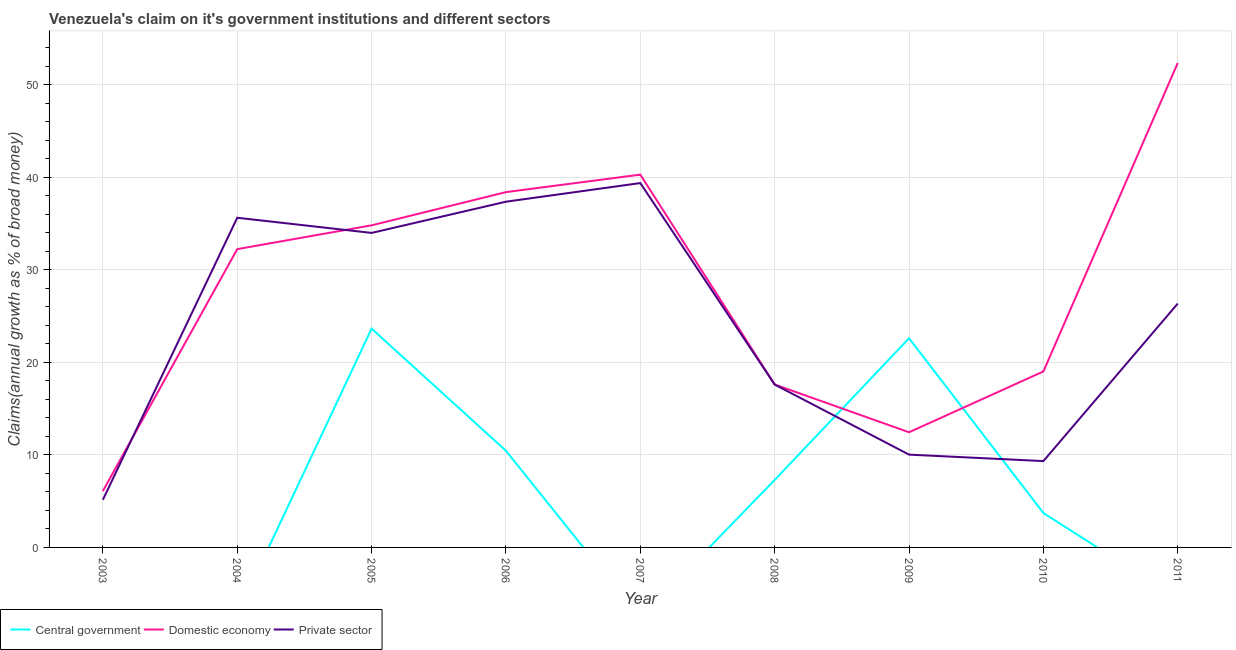What is the percentage of claim on the private sector in 2004?
Your answer should be very brief. 35.64. Across all years, what is the maximum percentage of claim on the central government?
Your answer should be very brief. 23.66. What is the total percentage of claim on the domestic economy in the graph?
Your answer should be compact. 253.36. What is the difference between the percentage of claim on the private sector in 2005 and that in 2008?
Give a very brief answer. 16.4. What is the difference between the percentage of claim on the central government in 2006 and the percentage of claim on the private sector in 2004?
Keep it short and to the point. -25.19. What is the average percentage of claim on the central government per year?
Ensure brevity in your answer.  7.53. In the year 2008, what is the difference between the percentage of claim on the domestic economy and percentage of claim on the central government?
Your answer should be very brief. 10.32. What is the ratio of the percentage of claim on the central government in 2006 to that in 2010?
Provide a succinct answer. 2.81. What is the difference between the highest and the second highest percentage of claim on the central government?
Your response must be concise. 1.04. What is the difference between the highest and the lowest percentage of claim on the central government?
Provide a short and direct response. 23.66. Does the percentage of claim on the private sector monotonically increase over the years?
Your response must be concise. No. Is the percentage of claim on the domestic economy strictly greater than the percentage of claim on the central government over the years?
Provide a short and direct response. No. Is the percentage of claim on the domestic economy strictly less than the percentage of claim on the private sector over the years?
Provide a short and direct response. No. What is the difference between two consecutive major ticks on the Y-axis?
Your answer should be very brief. 10. Does the graph contain grids?
Make the answer very short. Yes. How many legend labels are there?
Your answer should be very brief. 3. What is the title of the graph?
Make the answer very short. Venezuela's claim on it's government institutions and different sectors. What is the label or title of the Y-axis?
Make the answer very short. Claims(annual growth as % of broad money). What is the Claims(annual growth as % of broad money) of Domestic economy in 2003?
Ensure brevity in your answer.  6.09. What is the Claims(annual growth as % of broad money) in Private sector in 2003?
Your answer should be very brief. 5.15. What is the Claims(annual growth as % of broad money) of Central government in 2004?
Provide a short and direct response. 0. What is the Claims(annual growth as % of broad money) in Domestic economy in 2004?
Your response must be concise. 32.25. What is the Claims(annual growth as % of broad money) in Private sector in 2004?
Make the answer very short. 35.64. What is the Claims(annual growth as % of broad money) in Central government in 2005?
Make the answer very short. 23.66. What is the Claims(annual growth as % of broad money) in Domestic economy in 2005?
Your answer should be very brief. 34.83. What is the Claims(annual growth as % of broad money) of Private sector in 2005?
Keep it short and to the point. 34.01. What is the Claims(annual growth as % of broad money) of Central government in 2006?
Offer a very short reply. 10.45. What is the Claims(annual growth as % of broad money) of Domestic economy in 2006?
Offer a terse response. 38.42. What is the Claims(annual growth as % of broad money) in Private sector in 2006?
Your answer should be very brief. 37.38. What is the Claims(annual growth as % of broad money) in Domestic economy in 2007?
Provide a succinct answer. 40.31. What is the Claims(annual growth as % of broad money) in Private sector in 2007?
Provide a short and direct response. 39.39. What is the Claims(annual growth as % of broad money) in Central government in 2008?
Make the answer very short. 7.29. What is the Claims(annual growth as % of broad money) of Domestic economy in 2008?
Offer a very short reply. 17.61. What is the Claims(annual growth as % of broad money) of Private sector in 2008?
Your response must be concise. 17.61. What is the Claims(annual growth as % of broad money) of Central government in 2009?
Your response must be concise. 22.61. What is the Claims(annual growth as % of broad money) of Domestic economy in 2009?
Your response must be concise. 12.45. What is the Claims(annual growth as % of broad money) of Private sector in 2009?
Give a very brief answer. 10.03. What is the Claims(annual growth as % of broad money) of Central government in 2010?
Ensure brevity in your answer.  3.72. What is the Claims(annual growth as % of broad money) of Domestic economy in 2010?
Your answer should be very brief. 19.03. What is the Claims(annual growth as % of broad money) of Private sector in 2010?
Ensure brevity in your answer.  9.33. What is the Claims(annual growth as % of broad money) in Central government in 2011?
Make the answer very short. 0. What is the Claims(annual growth as % of broad money) in Domestic economy in 2011?
Make the answer very short. 52.38. What is the Claims(annual growth as % of broad money) in Private sector in 2011?
Your answer should be very brief. 26.37. Across all years, what is the maximum Claims(annual growth as % of broad money) in Central government?
Provide a succinct answer. 23.66. Across all years, what is the maximum Claims(annual growth as % of broad money) in Domestic economy?
Offer a terse response. 52.38. Across all years, what is the maximum Claims(annual growth as % of broad money) in Private sector?
Offer a very short reply. 39.39. Across all years, what is the minimum Claims(annual growth as % of broad money) of Domestic economy?
Make the answer very short. 6.09. Across all years, what is the minimum Claims(annual growth as % of broad money) in Private sector?
Your answer should be very brief. 5.15. What is the total Claims(annual growth as % of broad money) in Central government in the graph?
Your response must be concise. 67.74. What is the total Claims(annual growth as % of broad money) of Domestic economy in the graph?
Provide a short and direct response. 253.36. What is the total Claims(annual growth as % of broad money) of Private sector in the graph?
Provide a short and direct response. 214.92. What is the difference between the Claims(annual growth as % of broad money) of Domestic economy in 2003 and that in 2004?
Your response must be concise. -26.16. What is the difference between the Claims(annual growth as % of broad money) of Private sector in 2003 and that in 2004?
Your answer should be very brief. -30.49. What is the difference between the Claims(annual growth as % of broad money) of Domestic economy in 2003 and that in 2005?
Provide a short and direct response. -28.73. What is the difference between the Claims(annual growth as % of broad money) in Private sector in 2003 and that in 2005?
Provide a succinct answer. -28.86. What is the difference between the Claims(annual growth as % of broad money) of Domestic economy in 2003 and that in 2006?
Provide a short and direct response. -32.32. What is the difference between the Claims(annual growth as % of broad money) in Private sector in 2003 and that in 2006?
Your response must be concise. -32.23. What is the difference between the Claims(annual growth as % of broad money) of Domestic economy in 2003 and that in 2007?
Your answer should be compact. -34.21. What is the difference between the Claims(annual growth as % of broad money) in Private sector in 2003 and that in 2007?
Your response must be concise. -34.24. What is the difference between the Claims(annual growth as % of broad money) in Domestic economy in 2003 and that in 2008?
Your answer should be very brief. -11.52. What is the difference between the Claims(annual growth as % of broad money) of Private sector in 2003 and that in 2008?
Offer a very short reply. -12.46. What is the difference between the Claims(annual growth as % of broad money) in Domestic economy in 2003 and that in 2009?
Make the answer very short. -6.36. What is the difference between the Claims(annual growth as % of broad money) in Private sector in 2003 and that in 2009?
Provide a succinct answer. -4.88. What is the difference between the Claims(annual growth as % of broad money) in Domestic economy in 2003 and that in 2010?
Make the answer very short. -12.93. What is the difference between the Claims(annual growth as % of broad money) in Private sector in 2003 and that in 2010?
Offer a very short reply. -4.18. What is the difference between the Claims(annual growth as % of broad money) in Domestic economy in 2003 and that in 2011?
Offer a very short reply. -46.28. What is the difference between the Claims(annual growth as % of broad money) of Private sector in 2003 and that in 2011?
Provide a short and direct response. -21.22. What is the difference between the Claims(annual growth as % of broad money) of Domestic economy in 2004 and that in 2005?
Provide a succinct answer. -2.58. What is the difference between the Claims(annual growth as % of broad money) in Private sector in 2004 and that in 2005?
Your answer should be compact. 1.64. What is the difference between the Claims(annual growth as % of broad money) in Domestic economy in 2004 and that in 2006?
Provide a succinct answer. -6.17. What is the difference between the Claims(annual growth as % of broad money) of Private sector in 2004 and that in 2006?
Offer a terse response. -1.74. What is the difference between the Claims(annual growth as % of broad money) in Domestic economy in 2004 and that in 2007?
Ensure brevity in your answer.  -8.06. What is the difference between the Claims(annual growth as % of broad money) of Private sector in 2004 and that in 2007?
Ensure brevity in your answer.  -3.75. What is the difference between the Claims(annual growth as % of broad money) of Domestic economy in 2004 and that in 2008?
Offer a terse response. 14.64. What is the difference between the Claims(annual growth as % of broad money) of Private sector in 2004 and that in 2008?
Give a very brief answer. 18.03. What is the difference between the Claims(annual growth as % of broad money) of Domestic economy in 2004 and that in 2009?
Provide a short and direct response. 19.8. What is the difference between the Claims(annual growth as % of broad money) in Private sector in 2004 and that in 2009?
Ensure brevity in your answer.  25.61. What is the difference between the Claims(annual growth as % of broad money) of Domestic economy in 2004 and that in 2010?
Offer a terse response. 13.22. What is the difference between the Claims(annual growth as % of broad money) of Private sector in 2004 and that in 2010?
Your answer should be compact. 26.31. What is the difference between the Claims(annual growth as % of broad money) of Domestic economy in 2004 and that in 2011?
Provide a succinct answer. -20.13. What is the difference between the Claims(annual growth as % of broad money) in Private sector in 2004 and that in 2011?
Offer a very short reply. 9.28. What is the difference between the Claims(annual growth as % of broad money) in Central government in 2005 and that in 2006?
Provide a succinct answer. 13.21. What is the difference between the Claims(annual growth as % of broad money) in Domestic economy in 2005 and that in 2006?
Give a very brief answer. -3.59. What is the difference between the Claims(annual growth as % of broad money) of Private sector in 2005 and that in 2006?
Provide a succinct answer. -3.37. What is the difference between the Claims(annual growth as % of broad money) in Domestic economy in 2005 and that in 2007?
Ensure brevity in your answer.  -5.48. What is the difference between the Claims(annual growth as % of broad money) of Private sector in 2005 and that in 2007?
Give a very brief answer. -5.39. What is the difference between the Claims(annual growth as % of broad money) in Central government in 2005 and that in 2008?
Make the answer very short. 16.36. What is the difference between the Claims(annual growth as % of broad money) in Domestic economy in 2005 and that in 2008?
Make the answer very short. 17.21. What is the difference between the Claims(annual growth as % of broad money) in Private sector in 2005 and that in 2008?
Your answer should be very brief. 16.4. What is the difference between the Claims(annual growth as % of broad money) in Central government in 2005 and that in 2009?
Offer a very short reply. 1.04. What is the difference between the Claims(annual growth as % of broad money) of Domestic economy in 2005 and that in 2009?
Offer a very short reply. 22.37. What is the difference between the Claims(annual growth as % of broad money) of Private sector in 2005 and that in 2009?
Provide a succinct answer. 23.97. What is the difference between the Claims(annual growth as % of broad money) of Central government in 2005 and that in 2010?
Your answer should be very brief. 19.94. What is the difference between the Claims(annual growth as % of broad money) in Domestic economy in 2005 and that in 2010?
Offer a terse response. 15.8. What is the difference between the Claims(annual growth as % of broad money) of Private sector in 2005 and that in 2010?
Your answer should be very brief. 24.67. What is the difference between the Claims(annual growth as % of broad money) of Domestic economy in 2005 and that in 2011?
Offer a very short reply. -17.55. What is the difference between the Claims(annual growth as % of broad money) of Private sector in 2005 and that in 2011?
Ensure brevity in your answer.  7.64. What is the difference between the Claims(annual growth as % of broad money) in Domestic economy in 2006 and that in 2007?
Offer a very short reply. -1.89. What is the difference between the Claims(annual growth as % of broad money) of Private sector in 2006 and that in 2007?
Give a very brief answer. -2.01. What is the difference between the Claims(annual growth as % of broad money) in Central government in 2006 and that in 2008?
Offer a terse response. 3.16. What is the difference between the Claims(annual growth as % of broad money) in Domestic economy in 2006 and that in 2008?
Offer a terse response. 20.8. What is the difference between the Claims(annual growth as % of broad money) in Private sector in 2006 and that in 2008?
Ensure brevity in your answer.  19.77. What is the difference between the Claims(annual growth as % of broad money) of Central government in 2006 and that in 2009?
Make the answer very short. -12.16. What is the difference between the Claims(annual growth as % of broad money) of Domestic economy in 2006 and that in 2009?
Keep it short and to the point. 25.96. What is the difference between the Claims(annual growth as % of broad money) in Private sector in 2006 and that in 2009?
Provide a succinct answer. 27.35. What is the difference between the Claims(annual growth as % of broad money) of Central government in 2006 and that in 2010?
Give a very brief answer. 6.73. What is the difference between the Claims(annual growth as % of broad money) of Domestic economy in 2006 and that in 2010?
Your answer should be compact. 19.39. What is the difference between the Claims(annual growth as % of broad money) of Private sector in 2006 and that in 2010?
Offer a terse response. 28.05. What is the difference between the Claims(annual growth as % of broad money) in Domestic economy in 2006 and that in 2011?
Offer a terse response. -13.96. What is the difference between the Claims(annual growth as % of broad money) in Private sector in 2006 and that in 2011?
Offer a terse response. 11.01. What is the difference between the Claims(annual growth as % of broad money) of Domestic economy in 2007 and that in 2008?
Keep it short and to the point. 22.69. What is the difference between the Claims(annual growth as % of broad money) in Private sector in 2007 and that in 2008?
Your answer should be compact. 21.78. What is the difference between the Claims(annual growth as % of broad money) in Domestic economy in 2007 and that in 2009?
Offer a terse response. 27.86. What is the difference between the Claims(annual growth as % of broad money) of Private sector in 2007 and that in 2009?
Provide a short and direct response. 29.36. What is the difference between the Claims(annual growth as % of broad money) of Domestic economy in 2007 and that in 2010?
Your answer should be very brief. 21.28. What is the difference between the Claims(annual growth as % of broad money) of Private sector in 2007 and that in 2010?
Provide a short and direct response. 30.06. What is the difference between the Claims(annual growth as % of broad money) in Domestic economy in 2007 and that in 2011?
Offer a very short reply. -12.07. What is the difference between the Claims(annual growth as % of broad money) of Private sector in 2007 and that in 2011?
Your answer should be compact. 13.03. What is the difference between the Claims(annual growth as % of broad money) of Central government in 2008 and that in 2009?
Your answer should be very brief. -15.32. What is the difference between the Claims(annual growth as % of broad money) in Domestic economy in 2008 and that in 2009?
Your answer should be compact. 5.16. What is the difference between the Claims(annual growth as % of broad money) in Private sector in 2008 and that in 2009?
Give a very brief answer. 7.58. What is the difference between the Claims(annual growth as % of broad money) of Central government in 2008 and that in 2010?
Your answer should be very brief. 3.57. What is the difference between the Claims(annual growth as % of broad money) of Domestic economy in 2008 and that in 2010?
Your response must be concise. -1.41. What is the difference between the Claims(annual growth as % of broad money) of Private sector in 2008 and that in 2010?
Ensure brevity in your answer.  8.27. What is the difference between the Claims(annual growth as % of broad money) in Domestic economy in 2008 and that in 2011?
Offer a very short reply. -34.77. What is the difference between the Claims(annual growth as % of broad money) of Private sector in 2008 and that in 2011?
Your answer should be very brief. -8.76. What is the difference between the Claims(annual growth as % of broad money) of Central government in 2009 and that in 2010?
Keep it short and to the point. 18.89. What is the difference between the Claims(annual growth as % of broad money) in Domestic economy in 2009 and that in 2010?
Offer a terse response. -6.57. What is the difference between the Claims(annual growth as % of broad money) in Private sector in 2009 and that in 2010?
Provide a succinct answer. 0.7. What is the difference between the Claims(annual growth as % of broad money) in Domestic economy in 2009 and that in 2011?
Your response must be concise. -39.93. What is the difference between the Claims(annual growth as % of broad money) of Private sector in 2009 and that in 2011?
Ensure brevity in your answer.  -16.33. What is the difference between the Claims(annual growth as % of broad money) of Domestic economy in 2010 and that in 2011?
Make the answer very short. -33.35. What is the difference between the Claims(annual growth as % of broad money) of Private sector in 2010 and that in 2011?
Your answer should be very brief. -17.03. What is the difference between the Claims(annual growth as % of broad money) of Domestic economy in 2003 and the Claims(annual growth as % of broad money) of Private sector in 2004?
Ensure brevity in your answer.  -29.55. What is the difference between the Claims(annual growth as % of broad money) of Domestic economy in 2003 and the Claims(annual growth as % of broad money) of Private sector in 2005?
Make the answer very short. -27.91. What is the difference between the Claims(annual growth as % of broad money) of Domestic economy in 2003 and the Claims(annual growth as % of broad money) of Private sector in 2006?
Your response must be concise. -31.29. What is the difference between the Claims(annual growth as % of broad money) of Domestic economy in 2003 and the Claims(annual growth as % of broad money) of Private sector in 2007?
Give a very brief answer. -33.3. What is the difference between the Claims(annual growth as % of broad money) in Domestic economy in 2003 and the Claims(annual growth as % of broad money) in Private sector in 2008?
Your response must be concise. -11.52. What is the difference between the Claims(annual growth as % of broad money) of Domestic economy in 2003 and the Claims(annual growth as % of broad money) of Private sector in 2009?
Give a very brief answer. -3.94. What is the difference between the Claims(annual growth as % of broad money) in Domestic economy in 2003 and the Claims(annual growth as % of broad money) in Private sector in 2010?
Give a very brief answer. -3.24. What is the difference between the Claims(annual growth as % of broad money) in Domestic economy in 2003 and the Claims(annual growth as % of broad money) in Private sector in 2011?
Provide a short and direct response. -20.27. What is the difference between the Claims(annual growth as % of broad money) of Domestic economy in 2004 and the Claims(annual growth as % of broad money) of Private sector in 2005?
Your answer should be very brief. -1.76. What is the difference between the Claims(annual growth as % of broad money) of Domestic economy in 2004 and the Claims(annual growth as % of broad money) of Private sector in 2006?
Ensure brevity in your answer.  -5.13. What is the difference between the Claims(annual growth as % of broad money) of Domestic economy in 2004 and the Claims(annual growth as % of broad money) of Private sector in 2007?
Provide a succinct answer. -7.14. What is the difference between the Claims(annual growth as % of broad money) in Domestic economy in 2004 and the Claims(annual growth as % of broad money) in Private sector in 2008?
Your answer should be very brief. 14.64. What is the difference between the Claims(annual growth as % of broad money) of Domestic economy in 2004 and the Claims(annual growth as % of broad money) of Private sector in 2009?
Your answer should be very brief. 22.22. What is the difference between the Claims(annual growth as % of broad money) of Domestic economy in 2004 and the Claims(annual growth as % of broad money) of Private sector in 2010?
Offer a terse response. 22.91. What is the difference between the Claims(annual growth as % of broad money) in Domestic economy in 2004 and the Claims(annual growth as % of broad money) in Private sector in 2011?
Your answer should be compact. 5.88. What is the difference between the Claims(annual growth as % of broad money) of Central government in 2005 and the Claims(annual growth as % of broad money) of Domestic economy in 2006?
Your response must be concise. -14.76. What is the difference between the Claims(annual growth as % of broad money) of Central government in 2005 and the Claims(annual growth as % of broad money) of Private sector in 2006?
Your answer should be compact. -13.72. What is the difference between the Claims(annual growth as % of broad money) in Domestic economy in 2005 and the Claims(annual growth as % of broad money) in Private sector in 2006?
Keep it short and to the point. -2.55. What is the difference between the Claims(annual growth as % of broad money) in Central government in 2005 and the Claims(annual growth as % of broad money) in Domestic economy in 2007?
Your answer should be very brief. -16.65. What is the difference between the Claims(annual growth as % of broad money) in Central government in 2005 and the Claims(annual growth as % of broad money) in Private sector in 2007?
Provide a short and direct response. -15.74. What is the difference between the Claims(annual growth as % of broad money) in Domestic economy in 2005 and the Claims(annual growth as % of broad money) in Private sector in 2007?
Offer a terse response. -4.57. What is the difference between the Claims(annual growth as % of broad money) of Central government in 2005 and the Claims(annual growth as % of broad money) of Domestic economy in 2008?
Provide a succinct answer. 6.04. What is the difference between the Claims(annual growth as % of broad money) of Central government in 2005 and the Claims(annual growth as % of broad money) of Private sector in 2008?
Your response must be concise. 6.05. What is the difference between the Claims(annual growth as % of broad money) of Domestic economy in 2005 and the Claims(annual growth as % of broad money) of Private sector in 2008?
Ensure brevity in your answer.  17.22. What is the difference between the Claims(annual growth as % of broad money) of Central government in 2005 and the Claims(annual growth as % of broad money) of Domestic economy in 2009?
Ensure brevity in your answer.  11.21. What is the difference between the Claims(annual growth as % of broad money) of Central government in 2005 and the Claims(annual growth as % of broad money) of Private sector in 2009?
Ensure brevity in your answer.  13.62. What is the difference between the Claims(annual growth as % of broad money) in Domestic economy in 2005 and the Claims(annual growth as % of broad money) in Private sector in 2009?
Offer a very short reply. 24.79. What is the difference between the Claims(annual growth as % of broad money) of Central government in 2005 and the Claims(annual growth as % of broad money) of Domestic economy in 2010?
Give a very brief answer. 4.63. What is the difference between the Claims(annual growth as % of broad money) in Central government in 2005 and the Claims(annual growth as % of broad money) in Private sector in 2010?
Keep it short and to the point. 14.32. What is the difference between the Claims(annual growth as % of broad money) in Domestic economy in 2005 and the Claims(annual growth as % of broad money) in Private sector in 2010?
Ensure brevity in your answer.  25.49. What is the difference between the Claims(annual growth as % of broad money) of Central government in 2005 and the Claims(annual growth as % of broad money) of Domestic economy in 2011?
Your response must be concise. -28.72. What is the difference between the Claims(annual growth as % of broad money) in Central government in 2005 and the Claims(annual growth as % of broad money) in Private sector in 2011?
Make the answer very short. -2.71. What is the difference between the Claims(annual growth as % of broad money) of Domestic economy in 2005 and the Claims(annual growth as % of broad money) of Private sector in 2011?
Offer a very short reply. 8.46. What is the difference between the Claims(annual growth as % of broad money) in Central government in 2006 and the Claims(annual growth as % of broad money) in Domestic economy in 2007?
Offer a very short reply. -29.86. What is the difference between the Claims(annual growth as % of broad money) of Central government in 2006 and the Claims(annual growth as % of broad money) of Private sector in 2007?
Offer a very short reply. -28.94. What is the difference between the Claims(annual growth as % of broad money) in Domestic economy in 2006 and the Claims(annual growth as % of broad money) in Private sector in 2007?
Ensure brevity in your answer.  -0.98. What is the difference between the Claims(annual growth as % of broad money) in Central government in 2006 and the Claims(annual growth as % of broad money) in Domestic economy in 2008?
Provide a succinct answer. -7.16. What is the difference between the Claims(annual growth as % of broad money) of Central government in 2006 and the Claims(annual growth as % of broad money) of Private sector in 2008?
Provide a succinct answer. -7.16. What is the difference between the Claims(annual growth as % of broad money) in Domestic economy in 2006 and the Claims(annual growth as % of broad money) in Private sector in 2008?
Offer a very short reply. 20.81. What is the difference between the Claims(annual growth as % of broad money) in Central government in 2006 and the Claims(annual growth as % of broad money) in Domestic economy in 2009?
Your response must be concise. -2. What is the difference between the Claims(annual growth as % of broad money) of Central government in 2006 and the Claims(annual growth as % of broad money) of Private sector in 2009?
Provide a succinct answer. 0.42. What is the difference between the Claims(annual growth as % of broad money) in Domestic economy in 2006 and the Claims(annual growth as % of broad money) in Private sector in 2009?
Make the answer very short. 28.38. What is the difference between the Claims(annual growth as % of broad money) in Central government in 2006 and the Claims(annual growth as % of broad money) in Domestic economy in 2010?
Provide a succinct answer. -8.57. What is the difference between the Claims(annual growth as % of broad money) in Central government in 2006 and the Claims(annual growth as % of broad money) in Private sector in 2010?
Give a very brief answer. 1.12. What is the difference between the Claims(annual growth as % of broad money) in Domestic economy in 2006 and the Claims(annual growth as % of broad money) in Private sector in 2010?
Keep it short and to the point. 29.08. What is the difference between the Claims(annual growth as % of broad money) of Central government in 2006 and the Claims(annual growth as % of broad money) of Domestic economy in 2011?
Keep it short and to the point. -41.93. What is the difference between the Claims(annual growth as % of broad money) of Central government in 2006 and the Claims(annual growth as % of broad money) of Private sector in 2011?
Provide a succinct answer. -15.91. What is the difference between the Claims(annual growth as % of broad money) in Domestic economy in 2006 and the Claims(annual growth as % of broad money) in Private sector in 2011?
Provide a short and direct response. 12.05. What is the difference between the Claims(annual growth as % of broad money) in Domestic economy in 2007 and the Claims(annual growth as % of broad money) in Private sector in 2008?
Offer a terse response. 22.7. What is the difference between the Claims(annual growth as % of broad money) of Domestic economy in 2007 and the Claims(annual growth as % of broad money) of Private sector in 2009?
Your answer should be compact. 30.27. What is the difference between the Claims(annual growth as % of broad money) of Domestic economy in 2007 and the Claims(annual growth as % of broad money) of Private sector in 2010?
Make the answer very short. 30.97. What is the difference between the Claims(annual growth as % of broad money) of Domestic economy in 2007 and the Claims(annual growth as % of broad money) of Private sector in 2011?
Your response must be concise. 13.94. What is the difference between the Claims(annual growth as % of broad money) in Central government in 2008 and the Claims(annual growth as % of broad money) in Domestic economy in 2009?
Offer a terse response. -5.16. What is the difference between the Claims(annual growth as % of broad money) in Central government in 2008 and the Claims(annual growth as % of broad money) in Private sector in 2009?
Keep it short and to the point. -2.74. What is the difference between the Claims(annual growth as % of broad money) in Domestic economy in 2008 and the Claims(annual growth as % of broad money) in Private sector in 2009?
Offer a very short reply. 7.58. What is the difference between the Claims(annual growth as % of broad money) of Central government in 2008 and the Claims(annual growth as % of broad money) of Domestic economy in 2010?
Offer a terse response. -11.73. What is the difference between the Claims(annual growth as % of broad money) of Central government in 2008 and the Claims(annual growth as % of broad money) of Private sector in 2010?
Offer a terse response. -2.04. What is the difference between the Claims(annual growth as % of broad money) of Domestic economy in 2008 and the Claims(annual growth as % of broad money) of Private sector in 2010?
Your response must be concise. 8.28. What is the difference between the Claims(annual growth as % of broad money) in Central government in 2008 and the Claims(annual growth as % of broad money) in Domestic economy in 2011?
Make the answer very short. -45.09. What is the difference between the Claims(annual growth as % of broad money) of Central government in 2008 and the Claims(annual growth as % of broad money) of Private sector in 2011?
Provide a succinct answer. -19.07. What is the difference between the Claims(annual growth as % of broad money) of Domestic economy in 2008 and the Claims(annual growth as % of broad money) of Private sector in 2011?
Provide a short and direct response. -8.75. What is the difference between the Claims(annual growth as % of broad money) of Central government in 2009 and the Claims(annual growth as % of broad money) of Domestic economy in 2010?
Your answer should be compact. 3.59. What is the difference between the Claims(annual growth as % of broad money) of Central government in 2009 and the Claims(annual growth as % of broad money) of Private sector in 2010?
Your answer should be compact. 13.28. What is the difference between the Claims(annual growth as % of broad money) in Domestic economy in 2009 and the Claims(annual growth as % of broad money) in Private sector in 2010?
Give a very brief answer. 3.12. What is the difference between the Claims(annual growth as % of broad money) of Central government in 2009 and the Claims(annual growth as % of broad money) of Domestic economy in 2011?
Your answer should be compact. -29.77. What is the difference between the Claims(annual growth as % of broad money) of Central government in 2009 and the Claims(annual growth as % of broad money) of Private sector in 2011?
Keep it short and to the point. -3.75. What is the difference between the Claims(annual growth as % of broad money) of Domestic economy in 2009 and the Claims(annual growth as % of broad money) of Private sector in 2011?
Keep it short and to the point. -13.91. What is the difference between the Claims(annual growth as % of broad money) in Central government in 2010 and the Claims(annual growth as % of broad money) in Domestic economy in 2011?
Ensure brevity in your answer.  -48.66. What is the difference between the Claims(annual growth as % of broad money) of Central government in 2010 and the Claims(annual growth as % of broad money) of Private sector in 2011?
Keep it short and to the point. -22.64. What is the difference between the Claims(annual growth as % of broad money) of Domestic economy in 2010 and the Claims(annual growth as % of broad money) of Private sector in 2011?
Make the answer very short. -7.34. What is the average Claims(annual growth as % of broad money) of Central government per year?
Keep it short and to the point. 7.53. What is the average Claims(annual growth as % of broad money) in Domestic economy per year?
Provide a succinct answer. 28.15. What is the average Claims(annual growth as % of broad money) of Private sector per year?
Provide a succinct answer. 23.88. In the year 2003, what is the difference between the Claims(annual growth as % of broad money) of Domestic economy and Claims(annual growth as % of broad money) of Private sector?
Provide a succinct answer. 0.94. In the year 2004, what is the difference between the Claims(annual growth as % of broad money) in Domestic economy and Claims(annual growth as % of broad money) in Private sector?
Your answer should be compact. -3.39. In the year 2005, what is the difference between the Claims(annual growth as % of broad money) in Central government and Claims(annual growth as % of broad money) in Domestic economy?
Offer a terse response. -11.17. In the year 2005, what is the difference between the Claims(annual growth as % of broad money) in Central government and Claims(annual growth as % of broad money) in Private sector?
Offer a terse response. -10.35. In the year 2005, what is the difference between the Claims(annual growth as % of broad money) of Domestic economy and Claims(annual growth as % of broad money) of Private sector?
Offer a very short reply. 0.82. In the year 2006, what is the difference between the Claims(annual growth as % of broad money) in Central government and Claims(annual growth as % of broad money) in Domestic economy?
Provide a short and direct response. -27.96. In the year 2006, what is the difference between the Claims(annual growth as % of broad money) in Central government and Claims(annual growth as % of broad money) in Private sector?
Offer a very short reply. -26.93. In the year 2006, what is the difference between the Claims(annual growth as % of broad money) of Domestic economy and Claims(annual growth as % of broad money) of Private sector?
Provide a succinct answer. 1.04. In the year 2007, what is the difference between the Claims(annual growth as % of broad money) in Domestic economy and Claims(annual growth as % of broad money) in Private sector?
Make the answer very short. 0.91. In the year 2008, what is the difference between the Claims(annual growth as % of broad money) of Central government and Claims(annual growth as % of broad money) of Domestic economy?
Provide a succinct answer. -10.32. In the year 2008, what is the difference between the Claims(annual growth as % of broad money) in Central government and Claims(annual growth as % of broad money) in Private sector?
Ensure brevity in your answer.  -10.32. In the year 2008, what is the difference between the Claims(annual growth as % of broad money) of Domestic economy and Claims(annual growth as % of broad money) of Private sector?
Keep it short and to the point. 0. In the year 2009, what is the difference between the Claims(annual growth as % of broad money) in Central government and Claims(annual growth as % of broad money) in Domestic economy?
Offer a terse response. 10.16. In the year 2009, what is the difference between the Claims(annual growth as % of broad money) in Central government and Claims(annual growth as % of broad money) in Private sector?
Offer a very short reply. 12.58. In the year 2009, what is the difference between the Claims(annual growth as % of broad money) in Domestic economy and Claims(annual growth as % of broad money) in Private sector?
Give a very brief answer. 2.42. In the year 2010, what is the difference between the Claims(annual growth as % of broad money) in Central government and Claims(annual growth as % of broad money) in Domestic economy?
Your answer should be very brief. -15.3. In the year 2010, what is the difference between the Claims(annual growth as % of broad money) of Central government and Claims(annual growth as % of broad money) of Private sector?
Provide a succinct answer. -5.61. In the year 2010, what is the difference between the Claims(annual growth as % of broad money) of Domestic economy and Claims(annual growth as % of broad money) of Private sector?
Offer a terse response. 9.69. In the year 2011, what is the difference between the Claims(annual growth as % of broad money) in Domestic economy and Claims(annual growth as % of broad money) in Private sector?
Give a very brief answer. 26.01. What is the ratio of the Claims(annual growth as % of broad money) of Domestic economy in 2003 to that in 2004?
Provide a short and direct response. 0.19. What is the ratio of the Claims(annual growth as % of broad money) of Private sector in 2003 to that in 2004?
Your answer should be very brief. 0.14. What is the ratio of the Claims(annual growth as % of broad money) of Domestic economy in 2003 to that in 2005?
Provide a succinct answer. 0.17. What is the ratio of the Claims(annual growth as % of broad money) in Private sector in 2003 to that in 2005?
Offer a terse response. 0.15. What is the ratio of the Claims(annual growth as % of broad money) in Domestic economy in 2003 to that in 2006?
Provide a short and direct response. 0.16. What is the ratio of the Claims(annual growth as % of broad money) in Private sector in 2003 to that in 2006?
Provide a short and direct response. 0.14. What is the ratio of the Claims(annual growth as % of broad money) of Domestic economy in 2003 to that in 2007?
Provide a short and direct response. 0.15. What is the ratio of the Claims(annual growth as % of broad money) of Private sector in 2003 to that in 2007?
Offer a terse response. 0.13. What is the ratio of the Claims(annual growth as % of broad money) of Domestic economy in 2003 to that in 2008?
Give a very brief answer. 0.35. What is the ratio of the Claims(annual growth as % of broad money) of Private sector in 2003 to that in 2008?
Offer a very short reply. 0.29. What is the ratio of the Claims(annual growth as % of broad money) in Domestic economy in 2003 to that in 2009?
Give a very brief answer. 0.49. What is the ratio of the Claims(annual growth as % of broad money) in Private sector in 2003 to that in 2009?
Ensure brevity in your answer.  0.51. What is the ratio of the Claims(annual growth as % of broad money) of Domestic economy in 2003 to that in 2010?
Keep it short and to the point. 0.32. What is the ratio of the Claims(annual growth as % of broad money) of Private sector in 2003 to that in 2010?
Give a very brief answer. 0.55. What is the ratio of the Claims(annual growth as % of broad money) in Domestic economy in 2003 to that in 2011?
Your response must be concise. 0.12. What is the ratio of the Claims(annual growth as % of broad money) in Private sector in 2003 to that in 2011?
Your answer should be very brief. 0.2. What is the ratio of the Claims(annual growth as % of broad money) of Domestic economy in 2004 to that in 2005?
Provide a short and direct response. 0.93. What is the ratio of the Claims(annual growth as % of broad money) in Private sector in 2004 to that in 2005?
Your answer should be compact. 1.05. What is the ratio of the Claims(annual growth as % of broad money) in Domestic economy in 2004 to that in 2006?
Your answer should be very brief. 0.84. What is the ratio of the Claims(annual growth as % of broad money) in Private sector in 2004 to that in 2006?
Keep it short and to the point. 0.95. What is the ratio of the Claims(annual growth as % of broad money) of Domestic economy in 2004 to that in 2007?
Your answer should be compact. 0.8. What is the ratio of the Claims(annual growth as % of broad money) in Private sector in 2004 to that in 2007?
Provide a short and direct response. 0.9. What is the ratio of the Claims(annual growth as % of broad money) of Domestic economy in 2004 to that in 2008?
Your answer should be compact. 1.83. What is the ratio of the Claims(annual growth as % of broad money) in Private sector in 2004 to that in 2008?
Provide a short and direct response. 2.02. What is the ratio of the Claims(annual growth as % of broad money) in Domestic economy in 2004 to that in 2009?
Offer a terse response. 2.59. What is the ratio of the Claims(annual growth as % of broad money) of Private sector in 2004 to that in 2009?
Give a very brief answer. 3.55. What is the ratio of the Claims(annual growth as % of broad money) in Domestic economy in 2004 to that in 2010?
Offer a very short reply. 1.7. What is the ratio of the Claims(annual growth as % of broad money) of Private sector in 2004 to that in 2010?
Your answer should be very brief. 3.82. What is the ratio of the Claims(annual growth as % of broad money) in Domestic economy in 2004 to that in 2011?
Offer a very short reply. 0.62. What is the ratio of the Claims(annual growth as % of broad money) in Private sector in 2004 to that in 2011?
Keep it short and to the point. 1.35. What is the ratio of the Claims(annual growth as % of broad money) in Central government in 2005 to that in 2006?
Provide a short and direct response. 2.26. What is the ratio of the Claims(annual growth as % of broad money) in Domestic economy in 2005 to that in 2006?
Your answer should be very brief. 0.91. What is the ratio of the Claims(annual growth as % of broad money) in Private sector in 2005 to that in 2006?
Provide a succinct answer. 0.91. What is the ratio of the Claims(annual growth as % of broad money) in Domestic economy in 2005 to that in 2007?
Offer a terse response. 0.86. What is the ratio of the Claims(annual growth as % of broad money) in Private sector in 2005 to that in 2007?
Your answer should be compact. 0.86. What is the ratio of the Claims(annual growth as % of broad money) of Central government in 2005 to that in 2008?
Provide a short and direct response. 3.24. What is the ratio of the Claims(annual growth as % of broad money) of Domestic economy in 2005 to that in 2008?
Give a very brief answer. 1.98. What is the ratio of the Claims(annual growth as % of broad money) of Private sector in 2005 to that in 2008?
Make the answer very short. 1.93. What is the ratio of the Claims(annual growth as % of broad money) in Central government in 2005 to that in 2009?
Your response must be concise. 1.05. What is the ratio of the Claims(annual growth as % of broad money) in Domestic economy in 2005 to that in 2009?
Offer a terse response. 2.8. What is the ratio of the Claims(annual growth as % of broad money) in Private sector in 2005 to that in 2009?
Offer a terse response. 3.39. What is the ratio of the Claims(annual growth as % of broad money) of Central government in 2005 to that in 2010?
Give a very brief answer. 6.36. What is the ratio of the Claims(annual growth as % of broad money) of Domestic economy in 2005 to that in 2010?
Ensure brevity in your answer.  1.83. What is the ratio of the Claims(annual growth as % of broad money) in Private sector in 2005 to that in 2010?
Make the answer very short. 3.64. What is the ratio of the Claims(annual growth as % of broad money) in Domestic economy in 2005 to that in 2011?
Provide a succinct answer. 0.66. What is the ratio of the Claims(annual growth as % of broad money) of Private sector in 2005 to that in 2011?
Ensure brevity in your answer.  1.29. What is the ratio of the Claims(annual growth as % of broad money) of Domestic economy in 2006 to that in 2007?
Ensure brevity in your answer.  0.95. What is the ratio of the Claims(annual growth as % of broad money) of Private sector in 2006 to that in 2007?
Keep it short and to the point. 0.95. What is the ratio of the Claims(annual growth as % of broad money) of Central government in 2006 to that in 2008?
Provide a succinct answer. 1.43. What is the ratio of the Claims(annual growth as % of broad money) in Domestic economy in 2006 to that in 2008?
Keep it short and to the point. 2.18. What is the ratio of the Claims(annual growth as % of broad money) of Private sector in 2006 to that in 2008?
Your answer should be very brief. 2.12. What is the ratio of the Claims(annual growth as % of broad money) in Central government in 2006 to that in 2009?
Your answer should be compact. 0.46. What is the ratio of the Claims(annual growth as % of broad money) in Domestic economy in 2006 to that in 2009?
Offer a terse response. 3.09. What is the ratio of the Claims(annual growth as % of broad money) in Private sector in 2006 to that in 2009?
Give a very brief answer. 3.73. What is the ratio of the Claims(annual growth as % of broad money) in Central government in 2006 to that in 2010?
Offer a terse response. 2.81. What is the ratio of the Claims(annual growth as % of broad money) of Domestic economy in 2006 to that in 2010?
Your answer should be very brief. 2.02. What is the ratio of the Claims(annual growth as % of broad money) in Private sector in 2006 to that in 2010?
Offer a terse response. 4. What is the ratio of the Claims(annual growth as % of broad money) of Domestic economy in 2006 to that in 2011?
Provide a short and direct response. 0.73. What is the ratio of the Claims(annual growth as % of broad money) of Private sector in 2006 to that in 2011?
Keep it short and to the point. 1.42. What is the ratio of the Claims(annual growth as % of broad money) in Domestic economy in 2007 to that in 2008?
Give a very brief answer. 2.29. What is the ratio of the Claims(annual growth as % of broad money) in Private sector in 2007 to that in 2008?
Offer a terse response. 2.24. What is the ratio of the Claims(annual growth as % of broad money) of Domestic economy in 2007 to that in 2009?
Provide a succinct answer. 3.24. What is the ratio of the Claims(annual growth as % of broad money) of Private sector in 2007 to that in 2009?
Provide a short and direct response. 3.93. What is the ratio of the Claims(annual growth as % of broad money) of Domestic economy in 2007 to that in 2010?
Offer a terse response. 2.12. What is the ratio of the Claims(annual growth as % of broad money) of Private sector in 2007 to that in 2010?
Keep it short and to the point. 4.22. What is the ratio of the Claims(annual growth as % of broad money) in Domestic economy in 2007 to that in 2011?
Ensure brevity in your answer.  0.77. What is the ratio of the Claims(annual growth as % of broad money) in Private sector in 2007 to that in 2011?
Give a very brief answer. 1.49. What is the ratio of the Claims(annual growth as % of broad money) of Central government in 2008 to that in 2009?
Ensure brevity in your answer.  0.32. What is the ratio of the Claims(annual growth as % of broad money) of Domestic economy in 2008 to that in 2009?
Offer a terse response. 1.41. What is the ratio of the Claims(annual growth as % of broad money) of Private sector in 2008 to that in 2009?
Provide a short and direct response. 1.75. What is the ratio of the Claims(annual growth as % of broad money) in Central government in 2008 to that in 2010?
Provide a succinct answer. 1.96. What is the ratio of the Claims(annual growth as % of broad money) in Domestic economy in 2008 to that in 2010?
Your answer should be very brief. 0.93. What is the ratio of the Claims(annual growth as % of broad money) of Private sector in 2008 to that in 2010?
Keep it short and to the point. 1.89. What is the ratio of the Claims(annual growth as % of broad money) of Domestic economy in 2008 to that in 2011?
Keep it short and to the point. 0.34. What is the ratio of the Claims(annual growth as % of broad money) in Private sector in 2008 to that in 2011?
Keep it short and to the point. 0.67. What is the ratio of the Claims(annual growth as % of broad money) of Central government in 2009 to that in 2010?
Your answer should be very brief. 6.08. What is the ratio of the Claims(annual growth as % of broad money) of Domestic economy in 2009 to that in 2010?
Make the answer very short. 0.65. What is the ratio of the Claims(annual growth as % of broad money) of Private sector in 2009 to that in 2010?
Provide a succinct answer. 1.07. What is the ratio of the Claims(annual growth as % of broad money) of Domestic economy in 2009 to that in 2011?
Make the answer very short. 0.24. What is the ratio of the Claims(annual growth as % of broad money) of Private sector in 2009 to that in 2011?
Offer a very short reply. 0.38. What is the ratio of the Claims(annual growth as % of broad money) in Domestic economy in 2010 to that in 2011?
Keep it short and to the point. 0.36. What is the ratio of the Claims(annual growth as % of broad money) in Private sector in 2010 to that in 2011?
Give a very brief answer. 0.35. What is the difference between the highest and the second highest Claims(annual growth as % of broad money) of Central government?
Give a very brief answer. 1.04. What is the difference between the highest and the second highest Claims(annual growth as % of broad money) in Domestic economy?
Your answer should be very brief. 12.07. What is the difference between the highest and the second highest Claims(annual growth as % of broad money) in Private sector?
Ensure brevity in your answer.  2.01. What is the difference between the highest and the lowest Claims(annual growth as % of broad money) of Central government?
Provide a short and direct response. 23.66. What is the difference between the highest and the lowest Claims(annual growth as % of broad money) of Domestic economy?
Your response must be concise. 46.28. What is the difference between the highest and the lowest Claims(annual growth as % of broad money) of Private sector?
Make the answer very short. 34.24. 